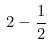<formula> <loc_0><loc_0><loc_500><loc_500>2 - \frac { 1 } { 2 }</formula> 